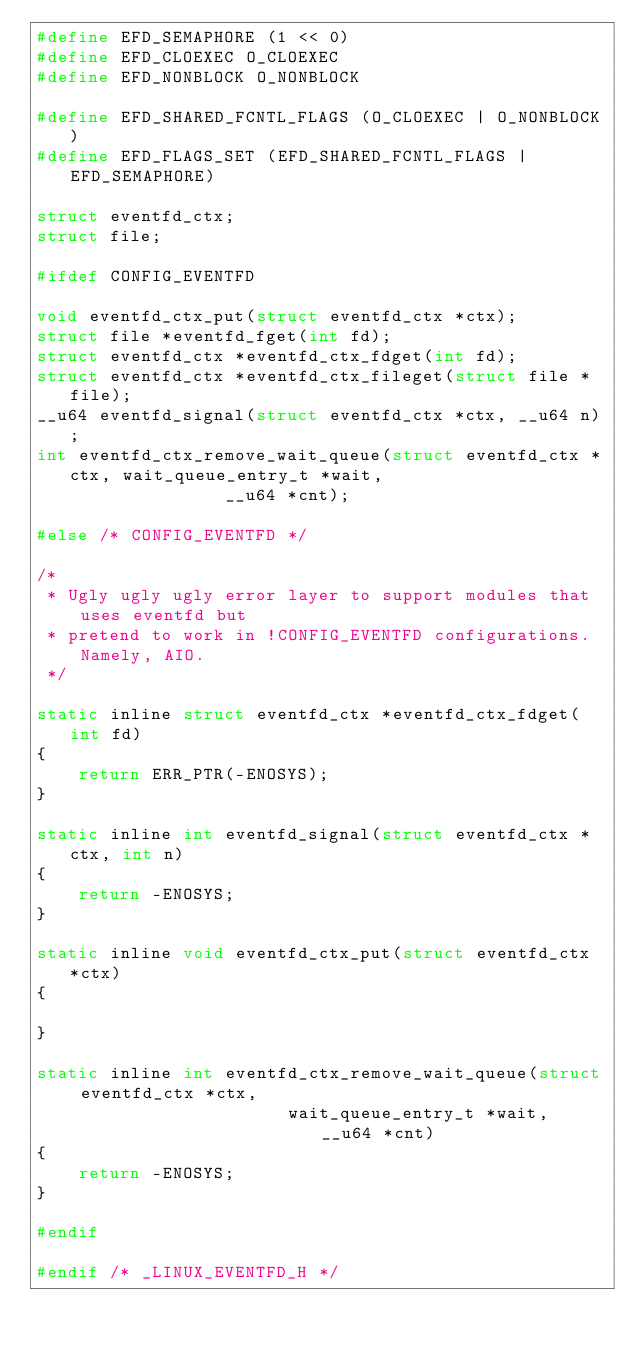Convert code to text. <code><loc_0><loc_0><loc_500><loc_500><_C_>#define EFD_SEMAPHORE (1 << 0)
#define EFD_CLOEXEC O_CLOEXEC
#define EFD_NONBLOCK O_NONBLOCK

#define EFD_SHARED_FCNTL_FLAGS (O_CLOEXEC | O_NONBLOCK)
#define EFD_FLAGS_SET (EFD_SHARED_FCNTL_FLAGS | EFD_SEMAPHORE)

struct eventfd_ctx;
struct file;

#ifdef CONFIG_EVENTFD

void eventfd_ctx_put(struct eventfd_ctx *ctx);
struct file *eventfd_fget(int fd);
struct eventfd_ctx *eventfd_ctx_fdget(int fd);
struct eventfd_ctx *eventfd_ctx_fileget(struct file *file);
__u64 eventfd_signal(struct eventfd_ctx *ctx, __u64 n);
int eventfd_ctx_remove_wait_queue(struct eventfd_ctx *ctx, wait_queue_entry_t *wait,
				  __u64 *cnt);

#else /* CONFIG_EVENTFD */

/*
 * Ugly ugly ugly error layer to support modules that uses eventfd but
 * pretend to work in !CONFIG_EVENTFD configurations. Namely, AIO.
 */

static inline struct eventfd_ctx *eventfd_ctx_fdget(int fd)
{
	return ERR_PTR(-ENOSYS);
}

static inline int eventfd_signal(struct eventfd_ctx *ctx, int n)
{
	return -ENOSYS;
}

static inline void eventfd_ctx_put(struct eventfd_ctx *ctx)
{

}

static inline int eventfd_ctx_remove_wait_queue(struct eventfd_ctx *ctx,
						wait_queue_entry_t *wait, __u64 *cnt)
{
	return -ENOSYS;
}

#endif

#endif /* _LINUX_EVENTFD_H */

</code> 